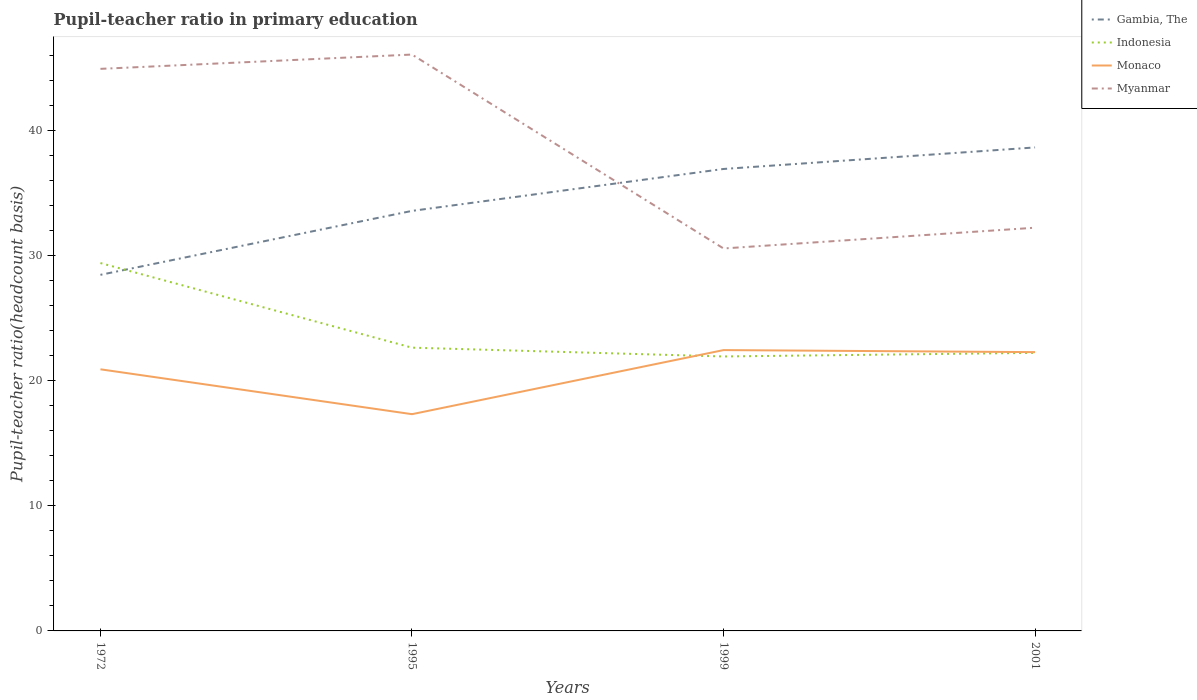How many different coloured lines are there?
Offer a very short reply. 4. Is the number of lines equal to the number of legend labels?
Your answer should be very brief. Yes. Across all years, what is the maximum pupil-teacher ratio in primary education in Indonesia?
Offer a very short reply. 21.96. In which year was the pupil-teacher ratio in primary education in Myanmar maximum?
Your answer should be very brief. 1999. What is the total pupil-teacher ratio in primary education in Monaco in the graph?
Offer a very short reply. 3.59. What is the difference between the highest and the second highest pupil-teacher ratio in primary education in Myanmar?
Provide a short and direct response. 15.51. What is the difference between the highest and the lowest pupil-teacher ratio in primary education in Monaco?
Provide a short and direct response. 3. How many years are there in the graph?
Make the answer very short. 4. What is the difference between two consecutive major ticks on the Y-axis?
Provide a succinct answer. 10. Does the graph contain any zero values?
Your answer should be compact. No. Does the graph contain grids?
Your answer should be very brief. No. How many legend labels are there?
Give a very brief answer. 4. What is the title of the graph?
Provide a succinct answer. Pupil-teacher ratio in primary education. Does "San Marino" appear as one of the legend labels in the graph?
Ensure brevity in your answer.  No. What is the label or title of the X-axis?
Provide a succinct answer. Years. What is the label or title of the Y-axis?
Give a very brief answer. Pupil-teacher ratio(headcount basis). What is the Pupil-teacher ratio(headcount basis) of Gambia, The in 1972?
Give a very brief answer. 28.49. What is the Pupil-teacher ratio(headcount basis) in Indonesia in 1972?
Your response must be concise. 29.43. What is the Pupil-teacher ratio(headcount basis) in Monaco in 1972?
Provide a short and direct response. 20.93. What is the Pupil-teacher ratio(headcount basis) of Myanmar in 1972?
Give a very brief answer. 44.97. What is the Pupil-teacher ratio(headcount basis) in Gambia, The in 1995?
Ensure brevity in your answer.  33.6. What is the Pupil-teacher ratio(headcount basis) of Indonesia in 1995?
Make the answer very short. 22.66. What is the Pupil-teacher ratio(headcount basis) in Monaco in 1995?
Make the answer very short. 17.34. What is the Pupil-teacher ratio(headcount basis) in Myanmar in 1995?
Your response must be concise. 46.11. What is the Pupil-teacher ratio(headcount basis) in Gambia, The in 1999?
Provide a short and direct response. 36.96. What is the Pupil-teacher ratio(headcount basis) in Indonesia in 1999?
Keep it short and to the point. 21.96. What is the Pupil-teacher ratio(headcount basis) of Monaco in 1999?
Ensure brevity in your answer.  22.47. What is the Pupil-teacher ratio(headcount basis) of Myanmar in 1999?
Offer a very short reply. 30.6. What is the Pupil-teacher ratio(headcount basis) in Gambia, The in 2001?
Offer a terse response. 38.68. What is the Pupil-teacher ratio(headcount basis) in Indonesia in 2001?
Provide a succinct answer. 22.25. What is the Pupil-teacher ratio(headcount basis) of Monaco in 2001?
Offer a terse response. 22.3. What is the Pupil-teacher ratio(headcount basis) in Myanmar in 2001?
Ensure brevity in your answer.  32.26. Across all years, what is the maximum Pupil-teacher ratio(headcount basis) in Gambia, The?
Offer a very short reply. 38.68. Across all years, what is the maximum Pupil-teacher ratio(headcount basis) in Indonesia?
Keep it short and to the point. 29.43. Across all years, what is the maximum Pupil-teacher ratio(headcount basis) in Monaco?
Provide a short and direct response. 22.47. Across all years, what is the maximum Pupil-teacher ratio(headcount basis) in Myanmar?
Your answer should be compact. 46.11. Across all years, what is the minimum Pupil-teacher ratio(headcount basis) of Gambia, The?
Provide a short and direct response. 28.49. Across all years, what is the minimum Pupil-teacher ratio(headcount basis) in Indonesia?
Ensure brevity in your answer.  21.96. Across all years, what is the minimum Pupil-teacher ratio(headcount basis) of Monaco?
Your answer should be very brief. 17.34. Across all years, what is the minimum Pupil-teacher ratio(headcount basis) in Myanmar?
Your response must be concise. 30.6. What is the total Pupil-teacher ratio(headcount basis) in Gambia, The in the graph?
Keep it short and to the point. 137.73. What is the total Pupil-teacher ratio(headcount basis) in Indonesia in the graph?
Offer a very short reply. 96.29. What is the total Pupil-teacher ratio(headcount basis) of Monaco in the graph?
Offer a terse response. 83.04. What is the total Pupil-teacher ratio(headcount basis) of Myanmar in the graph?
Ensure brevity in your answer.  153.93. What is the difference between the Pupil-teacher ratio(headcount basis) of Gambia, The in 1972 and that in 1995?
Keep it short and to the point. -5.11. What is the difference between the Pupil-teacher ratio(headcount basis) in Indonesia in 1972 and that in 1995?
Offer a terse response. 6.77. What is the difference between the Pupil-teacher ratio(headcount basis) of Monaco in 1972 and that in 1995?
Provide a succinct answer. 3.59. What is the difference between the Pupil-teacher ratio(headcount basis) of Myanmar in 1972 and that in 1995?
Make the answer very short. -1.14. What is the difference between the Pupil-teacher ratio(headcount basis) in Gambia, The in 1972 and that in 1999?
Ensure brevity in your answer.  -8.47. What is the difference between the Pupil-teacher ratio(headcount basis) of Indonesia in 1972 and that in 1999?
Make the answer very short. 7.47. What is the difference between the Pupil-teacher ratio(headcount basis) of Monaco in 1972 and that in 1999?
Provide a short and direct response. -1.54. What is the difference between the Pupil-teacher ratio(headcount basis) in Myanmar in 1972 and that in 1999?
Keep it short and to the point. 14.37. What is the difference between the Pupil-teacher ratio(headcount basis) in Gambia, The in 1972 and that in 2001?
Provide a short and direct response. -10.19. What is the difference between the Pupil-teacher ratio(headcount basis) of Indonesia in 1972 and that in 2001?
Make the answer very short. 7.18. What is the difference between the Pupil-teacher ratio(headcount basis) of Monaco in 1972 and that in 2001?
Offer a terse response. -1.37. What is the difference between the Pupil-teacher ratio(headcount basis) in Myanmar in 1972 and that in 2001?
Your answer should be very brief. 12.71. What is the difference between the Pupil-teacher ratio(headcount basis) of Gambia, The in 1995 and that in 1999?
Make the answer very short. -3.35. What is the difference between the Pupil-teacher ratio(headcount basis) in Indonesia in 1995 and that in 1999?
Ensure brevity in your answer.  0.7. What is the difference between the Pupil-teacher ratio(headcount basis) of Monaco in 1995 and that in 1999?
Your answer should be compact. -5.13. What is the difference between the Pupil-teacher ratio(headcount basis) in Myanmar in 1995 and that in 1999?
Provide a succinct answer. 15.51. What is the difference between the Pupil-teacher ratio(headcount basis) of Gambia, The in 1995 and that in 2001?
Keep it short and to the point. -5.08. What is the difference between the Pupil-teacher ratio(headcount basis) of Indonesia in 1995 and that in 2001?
Ensure brevity in your answer.  0.42. What is the difference between the Pupil-teacher ratio(headcount basis) of Monaco in 1995 and that in 2001?
Make the answer very short. -4.96. What is the difference between the Pupil-teacher ratio(headcount basis) in Myanmar in 1995 and that in 2001?
Provide a succinct answer. 13.85. What is the difference between the Pupil-teacher ratio(headcount basis) in Gambia, The in 1999 and that in 2001?
Offer a very short reply. -1.72. What is the difference between the Pupil-teacher ratio(headcount basis) of Indonesia in 1999 and that in 2001?
Ensure brevity in your answer.  -0.29. What is the difference between the Pupil-teacher ratio(headcount basis) in Monaco in 1999 and that in 2001?
Your answer should be very brief. 0.16. What is the difference between the Pupil-teacher ratio(headcount basis) of Myanmar in 1999 and that in 2001?
Your answer should be very brief. -1.66. What is the difference between the Pupil-teacher ratio(headcount basis) of Gambia, The in 1972 and the Pupil-teacher ratio(headcount basis) of Indonesia in 1995?
Offer a very short reply. 5.83. What is the difference between the Pupil-teacher ratio(headcount basis) of Gambia, The in 1972 and the Pupil-teacher ratio(headcount basis) of Monaco in 1995?
Ensure brevity in your answer.  11.15. What is the difference between the Pupil-teacher ratio(headcount basis) in Gambia, The in 1972 and the Pupil-teacher ratio(headcount basis) in Myanmar in 1995?
Your answer should be very brief. -17.62. What is the difference between the Pupil-teacher ratio(headcount basis) in Indonesia in 1972 and the Pupil-teacher ratio(headcount basis) in Monaco in 1995?
Your response must be concise. 12.09. What is the difference between the Pupil-teacher ratio(headcount basis) in Indonesia in 1972 and the Pupil-teacher ratio(headcount basis) in Myanmar in 1995?
Provide a succinct answer. -16.68. What is the difference between the Pupil-teacher ratio(headcount basis) in Monaco in 1972 and the Pupil-teacher ratio(headcount basis) in Myanmar in 1995?
Provide a short and direct response. -25.18. What is the difference between the Pupil-teacher ratio(headcount basis) in Gambia, The in 1972 and the Pupil-teacher ratio(headcount basis) in Indonesia in 1999?
Offer a very short reply. 6.53. What is the difference between the Pupil-teacher ratio(headcount basis) in Gambia, The in 1972 and the Pupil-teacher ratio(headcount basis) in Monaco in 1999?
Make the answer very short. 6.02. What is the difference between the Pupil-teacher ratio(headcount basis) of Gambia, The in 1972 and the Pupil-teacher ratio(headcount basis) of Myanmar in 1999?
Provide a succinct answer. -2.11. What is the difference between the Pupil-teacher ratio(headcount basis) of Indonesia in 1972 and the Pupil-teacher ratio(headcount basis) of Monaco in 1999?
Your response must be concise. 6.96. What is the difference between the Pupil-teacher ratio(headcount basis) in Indonesia in 1972 and the Pupil-teacher ratio(headcount basis) in Myanmar in 1999?
Your response must be concise. -1.17. What is the difference between the Pupil-teacher ratio(headcount basis) of Monaco in 1972 and the Pupil-teacher ratio(headcount basis) of Myanmar in 1999?
Keep it short and to the point. -9.67. What is the difference between the Pupil-teacher ratio(headcount basis) in Gambia, The in 1972 and the Pupil-teacher ratio(headcount basis) in Indonesia in 2001?
Offer a terse response. 6.24. What is the difference between the Pupil-teacher ratio(headcount basis) in Gambia, The in 1972 and the Pupil-teacher ratio(headcount basis) in Monaco in 2001?
Keep it short and to the point. 6.18. What is the difference between the Pupil-teacher ratio(headcount basis) of Gambia, The in 1972 and the Pupil-teacher ratio(headcount basis) of Myanmar in 2001?
Provide a succinct answer. -3.77. What is the difference between the Pupil-teacher ratio(headcount basis) of Indonesia in 1972 and the Pupil-teacher ratio(headcount basis) of Monaco in 2001?
Make the answer very short. 7.13. What is the difference between the Pupil-teacher ratio(headcount basis) of Indonesia in 1972 and the Pupil-teacher ratio(headcount basis) of Myanmar in 2001?
Offer a terse response. -2.83. What is the difference between the Pupil-teacher ratio(headcount basis) in Monaco in 1972 and the Pupil-teacher ratio(headcount basis) in Myanmar in 2001?
Offer a terse response. -11.33. What is the difference between the Pupil-teacher ratio(headcount basis) of Gambia, The in 1995 and the Pupil-teacher ratio(headcount basis) of Indonesia in 1999?
Keep it short and to the point. 11.65. What is the difference between the Pupil-teacher ratio(headcount basis) of Gambia, The in 1995 and the Pupil-teacher ratio(headcount basis) of Monaco in 1999?
Make the answer very short. 11.14. What is the difference between the Pupil-teacher ratio(headcount basis) of Gambia, The in 1995 and the Pupil-teacher ratio(headcount basis) of Myanmar in 1999?
Make the answer very short. 3.01. What is the difference between the Pupil-teacher ratio(headcount basis) of Indonesia in 1995 and the Pupil-teacher ratio(headcount basis) of Monaco in 1999?
Offer a terse response. 0.19. What is the difference between the Pupil-teacher ratio(headcount basis) of Indonesia in 1995 and the Pupil-teacher ratio(headcount basis) of Myanmar in 1999?
Provide a short and direct response. -7.94. What is the difference between the Pupil-teacher ratio(headcount basis) in Monaco in 1995 and the Pupil-teacher ratio(headcount basis) in Myanmar in 1999?
Ensure brevity in your answer.  -13.26. What is the difference between the Pupil-teacher ratio(headcount basis) of Gambia, The in 1995 and the Pupil-teacher ratio(headcount basis) of Indonesia in 2001?
Ensure brevity in your answer.  11.36. What is the difference between the Pupil-teacher ratio(headcount basis) in Gambia, The in 1995 and the Pupil-teacher ratio(headcount basis) in Monaco in 2001?
Provide a short and direct response. 11.3. What is the difference between the Pupil-teacher ratio(headcount basis) in Gambia, The in 1995 and the Pupil-teacher ratio(headcount basis) in Myanmar in 2001?
Give a very brief answer. 1.35. What is the difference between the Pupil-teacher ratio(headcount basis) of Indonesia in 1995 and the Pupil-teacher ratio(headcount basis) of Monaco in 2001?
Give a very brief answer. 0.36. What is the difference between the Pupil-teacher ratio(headcount basis) of Indonesia in 1995 and the Pupil-teacher ratio(headcount basis) of Myanmar in 2001?
Your answer should be very brief. -9.6. What is the difference between the Pupil-teacher ratio(headcount basis) in Monaco in 1995 and the Pupil-teacher ratio(headcount basis) in Myanmar in 2001?
Provide a short and direct response. -14.92. What is the difference between the Pupil-teacher ratio(headcount basis) in Gambia, The in 1999 and the Pupil-teacher ratio(headcount basis) in Indonesia in 2001?
Your answer should be compact. 14.71. What is the difference between the Pupil-teacher ratio(headcount basis) in Gambia, The in 1999 and the Pupil-teacher ratio(headcount basis) in Monaco in 2001?
Ensure brevity in your answer.  14.65. What is the difference between the Pupil-teacher ratio(headcount basis) in Gambia, The in 1999 and the Pupil-teacher ratio(headcount basis) in Myanmar in 2001?
Make the answer very short. 4.7. What is the difference between the Pupil-teacher ratio(headcount basis) in Indonesia in 1999 and the Pupil-teacher ratio(headcount basis) in Monaco in 2001?
Offer a very short reply. -0.35. What is the difference between the Pupil-teacher ratio(headcount basis) in Indonesia in 1999 and the Pupil-teacher ratio(headcount basis) in Myanmar in 2001?
Your response must be concise. -10.3. What is the difference between the Pupil-teacher ratio(headcount basis) of Monaco in 1999 and the Pupil-teacher ratio(headcount basis) of Myanmar in 2001?
Your answer should be compact. -9.79. What is the average Pupil-teacher ratio(headcount basis) of Gambia, The per year?
Make the answer very short. 34.43. What is the average Pupil-teacher ratio(headcount basis) of Indonesia per year?
Keep it short and to the point. 24.07. What is the average Pupil-teacher ratio(headcount basis) in Monaco per year?
Give a very brief answer. 20.76. What is the average Pupil-teacher ratio(headcount basis) in Myanmar per year?
Provide a short and direct response. 38.48. In the year 1972, what is the difference between the Pupil-teacher ratio(headcount basis) in Gambia, The and Pupil-teacher ratio(headcount basis) in Indonesia?
Provide a short and direct response. -0.94. In the year 1972, what is the difference between the Pupil-teacher ratio(headcount basis) of Gambia, The and Pupil-teacher ratio(headcount basis) of Monaco?
Your answer should be compact. 7.56. In the year 1972, what is the difference between the Pupil-teacher ratio(headcount basis) in Gambia, The and Pupil-teacher ratio(headcount basis) in Myanmar?
Your answer should be compact. -16.48. In the year 1972, what is the difference between the Pupil-teacher ratio(headcount basis) of Indonesia and Pupil-teacher ratio(headcount basis) of Monaco?
Provide a succinct answer. 8.5. In the year 1972, what is the difference between the Pupil-teacher ratio(headcount basis) in Indonesia and Pupil-teacher ratio(headcount basis) in Myanmar?
Your answer should be very brief. -15.54. In the year 1972, what is the difference between the Pupil-teacher ratio(headcount basis) of Monaco and Pupil-teacher ratio(headcount basis) of Myanmar?
Give a very brief answer. -24.04. In the year 1995, what is the difference between the Pupil-teacher ratio(headcount basis) of Gambia, The and Pupil-teacher ratio(headcount basis) of Indonesia?
Your response must be concise. 10.94. In the year 1995, what is the difference between the Pupil-teacher ratio(headcount basis) in Gambia, The and Pupil-teacher ratio(headcount basis) in Monaco?
Ensure brevity in your answer.  16.26. In the year 1995, what is the difference between the Pupil-teacher ratio(headcount basis) of Gambia, The and Pupil-teacher ratio(headcount basis) of Myanmar?
Ensure brevity in your answer.  -12.51. In the year 1995, what is the difference between the Pupil-teacher ratio(headcount basis) of Indonesia and Pupil-teacher ratio(headcount basis) of Monaco?
Offer a very short reply. 5.32. In the year 1995, what is the difference between the Pupil-teacher ratio(headcount basis) in Indonesia and Pupil-teacher ratio(headcount basis) in Myanmar?
Your answer should be very brief. -23.45. In the year 1995, what is the difference between the Pupil-teacher ratio(headcount basis) in Monaco and Pupil-teacher ratio(headcount basis) in Myanmar?
Keep it short and to the point. -28.77. In the year 1999, what is the difference between the Pupil-teacher ratio(headcount basis) in Gambia, The and Pupil-teacher ratio(headcount basis) in Indonesia?
Provide a succinct answer. 15. In the year 1999, what is the difference between the Pupil-teacher ratio(headcount basis) of Gambia, The and Pupil-teacher ratio(headcount basis) of Monaco?
Your response must be concise. 14.49. In the year 1999, what is the difference between the Pupil-teacher ratio(headcount basis) in Gambia, The and Pupil-teacher ratio(headcount basis) in Myanmar?
Your answer should be very brief. 6.36. In the year 1999, what is the difference between the Pupil-teacher ratio(headcount basis) of Indonesia and Pupil-teacher ratio(headcount basis) of Monaco?
Your response must be concise. -0.51. In the year 1999, what is the difference between the Pupil-teacher ratio(headcount basis) of Indonesia and Pupil-teacher ratio(headcount basis) of Myanmar?
Offer a terse response. -8.64. In the year 1999, what is the difference between the Pupil-teacher ratio(headcount basis) of Monaco and Pupil-teacher ratio(headcount basis) of Myanmar?
Your answer should be very brief. -8.13. In the year 2001, what is the difference between the Pupil-teacher ratio(headcount basis) of Gambia, The and Pupil-teacher ratio(headcount basis) of Indonesia?
Offer a very short reply. 16.43. In the year 2001, what is the difference between the Pupil-teacher ratio(headcount basis) of Gambia, The and Pupil-teacher ratio(headcount basis) of Monaco?
Provide a short and direct response. 16.38. In the year 2001, what is the difference between the Pupil-teacher ratio(headcount basis) of Gambia, The and Pupil-teacher ratio(headcount basis) of Myanmar?
Make the answer very short. 6.42. In the year 2001, what is the difference between the Pupil-teacher ratio(headcount basis) of Indonesia and Pupil-teacher ratio(headcount basis) of Monaco?
Offer a terse response. -0.06. In the year 2001, what is the difference between the Pupil-teacher ratio(headcount basis) in Indonesia and Pupil-teacher ratio(headcount basis) in Myanmar?
Give a very brief answer. -10.01. In the year 2001, what is the difference between the Pupil-teacher ratio(headcount basis) of Monaco and Pupil-teacher ratio(headcount basis) of Myanmar?
Your answer should be very brief. -9.95. What is the ratio of the Pupil-teacher ratio(headcount basis) in Gambia, The in 1972 to that in 1995?
Your response must be concise. 0.85. What is the ratio of the Pupil-teacher ratio(headcount basis) in Indonesia in 1972 to that in 1995?
Give a very brief answer. 1.3. What is the ratio of the Pupil-teacher ratio(headcount basis) of Monaco in 1972 to that in 1995?
Offer a very short reply. 1.21. What is the ratio of the Pupil-teacher ratio(headcount basis) of Myanmar in 1972 to that in 1995?
Your answer should be compact. 0.98. What is the ratio of the Pupil-teacher ratio(headcount basis) of Gambia, The in 1972 to that in 1999?
Your answer should be compact. 0.77. What is the ratio of the Pupil-teacher ratio(headcount basis) of Indonesia in 1972 to that in 1999?
Give a very brief answer. 1.34. What is the ratio of the Pupil-teacher ratio(headcount basis) in Monaco in 1972 to that in 1999?
Offer a terse response. 0.93. What is the ratio of the Pupil-teacher ratio(headcount basis) of Myanmar in 1972 to that in 1999?
Offer a terse response. 1.47. What is the ratio of the Pupil-teacher ratio(headcount basis) in Gambia, The in 1972 to that in 2001?
Keep it short and to the point. 0.74. What is the ratio of the Pupil-teacher ratio(headcount basis) in Indonesia in 1972 to that in 2001?
Your answer should be very brief. 1.32. What is the ratio of the Pupil-teacher ratio(headcount basis) of Monaco in 1972 to that in 2001?
Keep it short and to the point. 0.94. What is the ratio of the Pupil-teacher ratio(headcount basis) in Myanmar in 1972 to that in 2001?
Your answer should be very brief. 1.39. What is the ratio of the Pupil-teacher ratio(headcount basis) of Gambia, The in 1995 to that in 1999?
Provide a short and direct response. 0.91. What is the ratio of the Pupil-teacher ratio(headcount basis) of Indonesia in 1995 to that in 1999?
Your answer should be very brief. 1.03. What is the ratio of the Pupil-teacher ratio(headcount basis) in Monaco in 1995 to that in 1999?
Make the answer very short. 0.77. What is the ratio of the Pupil-teacher ratio(headcount basis) of Myanmar in 1995 to that in 1999?
Your response must be concise. 1.51. What is the ratio of the Pupil-teacher ratio(headcount basis) in Gambia, The in 1995 to that in 2001?
Your answer should be very brief. 0.87. What is the ratio of the Pupil-teacher ratio(headcount basis) of Indonesia in 1995 to that in 2001?
Ensure brevity in your answer.  1.02. What is the ratio of the Pupil-teacher ratio(headcount basis) of Monaco in 1995 to that in 2001?
Make the answer very short. 0.78. What is the ratio of the Pupil-teacher ratio(headcount basis) of Myanmar in 1995 to that in 2001?
Your response must be concise. 1.43. What is the ratio of the Pupil-teacher ratio(headcount basis) of Gambia, The in 1999 to that in 2001?
Your answer should be very brief. 0.96. What is the ratio of the Pupil-teacher ratio(headcount basis) of Monaco in 1999 to that in 2001?
Make the answer very short. 1.01. What is the ratio of the Pupil-teacher ratio(headcount basis) of Myanmar in 1999 to that in 2001?
Make the answer very short. 0.95. What is the difference between the highest and the second highest Pupil-teacher ratio(headcount basis) of Gambia, The?
Give a very brief answer. 1.72. What is the difference between the highest and the second highest Pupil-teacher ratio(headcount basis) in Indonesia?
Your response must be concise. 6.77. What is the difference between the highest and the second highest Pupil-teacher ratio(headcount basis) in Monaco?
Offer a terse response. 0.16. What is the difference between the highest and the second highest Pupil-teacher ratio(headcount basis) of Myanmar?
Make the answer very short. 1.14. What is the difference between the highest and the lowest Pupil-teacher ratio(headcount basis) in Gambia, The?
Offer a very short reply. 10.19. What is the difference between the highest and the lowest Pupil-teacher ratio(headcount basis) of Indonesia?
Keep it short and to the point. 7.47. What is the difference between the highest and the lowest Pupil-teacher ratio(headcount basis) in Monaco?
Provide a succinct answer. 5.13. What is the difference between the highest and the lowest Pupil-teacher ratio(headcount basis) of Myanmar?
Offer a terse response. 15.51. 